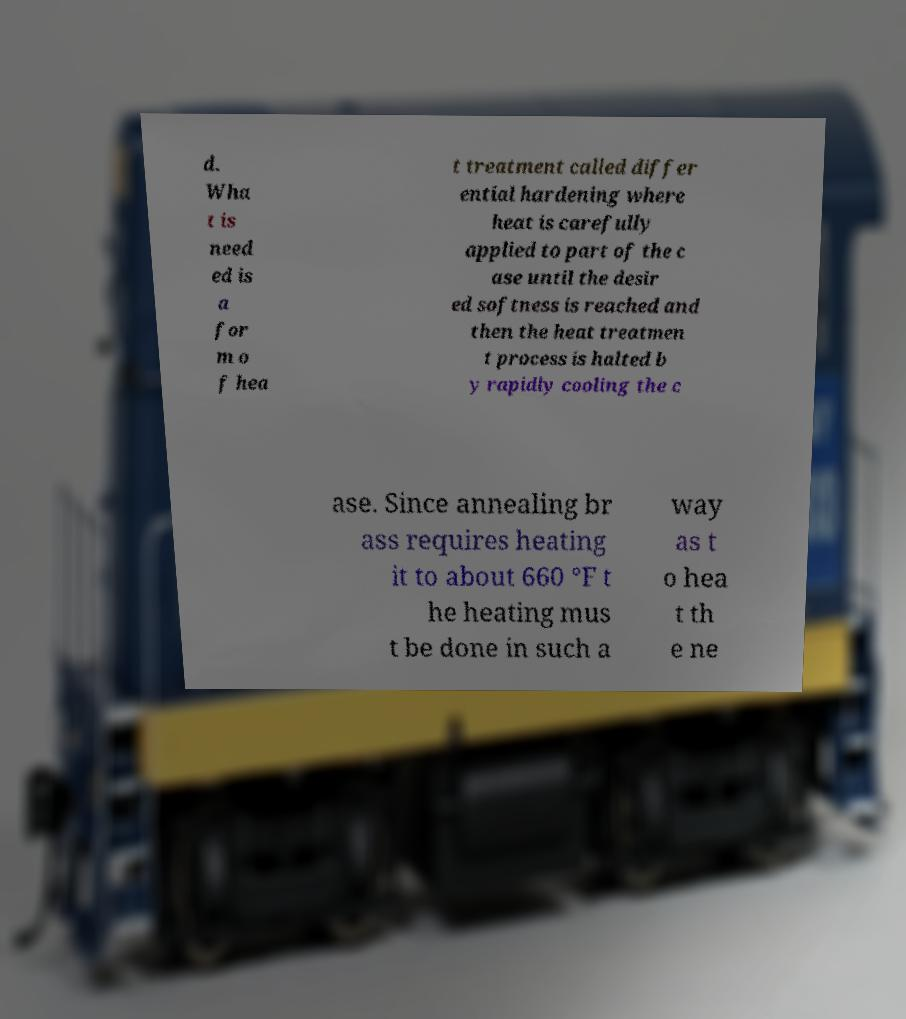Please identify and transcribe the text found in this image. d. Wha t is need ed is a for m o f hea t treatment called differ ential hardening where heat is carefully applied to part of the c ase until the desir ed softness is reached and then the heat treatmen t process is halted b y rapidly cooling the c ase. Since annealing br ass requires heating it to about 660 °F t he heating mus t be done in such a way as t o hea t th e ne 